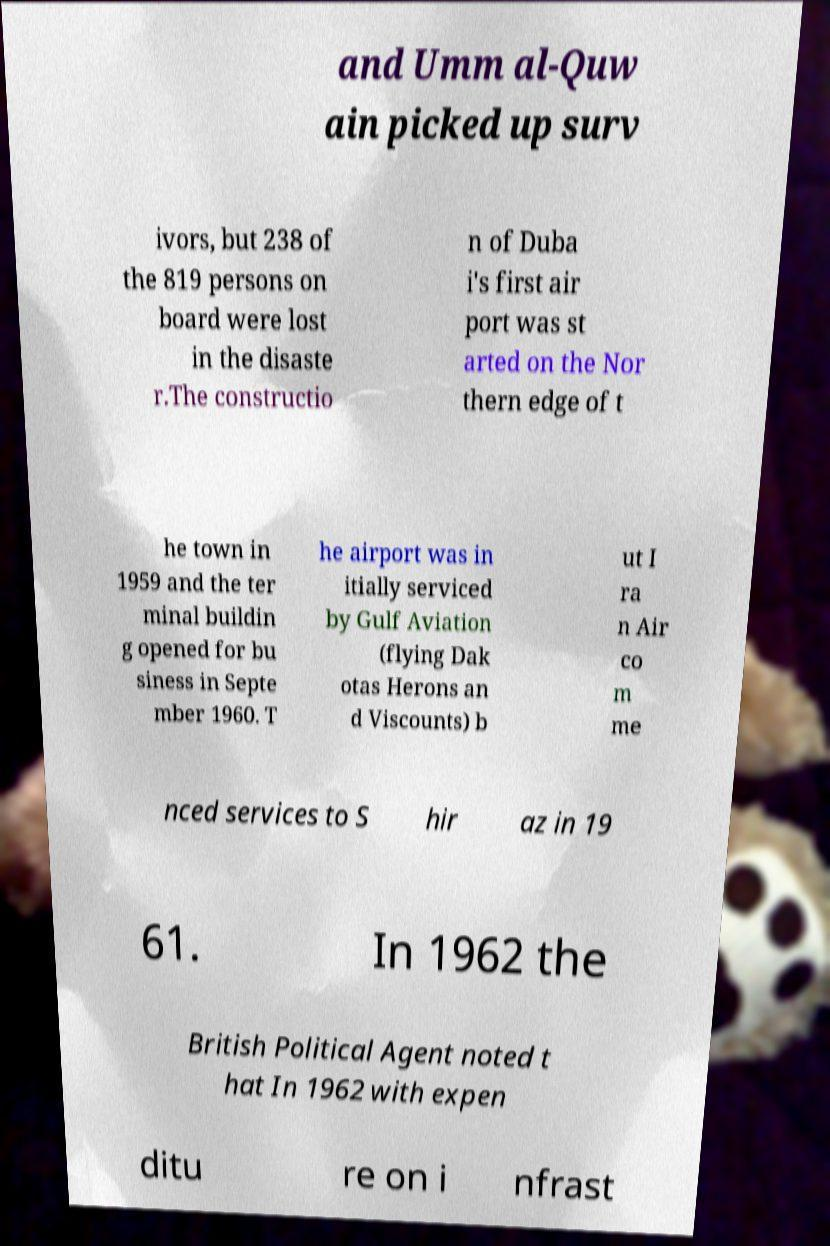Can you read and provide the text displayed in the image?This photo seems to have some interesting text. Can you extract and type it out for me? and Umm al-Quw ain picked up surv ivors, but 238 of the 819 persons on board were lost in the disaste r.The constructio n of Duba i's first air port was st arted on the Nor thern edge of t he town in 1959 and the ter minal buildin g opened for bu siness in Septe mber 1960. T he airport was in itially serviced by Gulf Aviation (flying Dak otas Herons an d Viscounts) b ut I ra n Air co m me nced services to S hir az in 19 61. In 1962 the British Political Agent noted t hat In 1962 with expen ditu re on i nfrast 